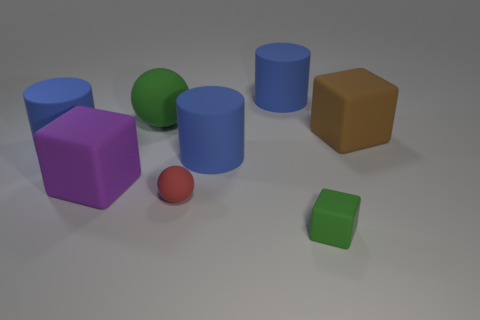What color is the other big rubber thing that is the same shape as the large purple rubber thing?
Keep it short and to the point. Brown. What material is the tiny cube that is the same color as the large ball?
Offer a very short reply. Rubber. Is there another large thing that has the same shape as the red thing?
Offer a terse response. Yes. What number of other things are there of the same color as the small matte block?
Ensure brevity in your answer.  1. Is the size of the rubber block behind the purple cube the same as the green object that is behind the tiny red matte object?
Keep it short and to the point. Yes. There is a cube that is in front of the big matte cube that is left of the tiny sphere; how big is it?
Ensure brevity in your answer.  Small. There is a block that is both in front of the large brown thing and behind the tiny red matte ball; what is its material?
Offer a very short reply. Rubber. The tiny rubber block is what color?
Ensure brevity in your answer.  Green. What shape is the green matte object that is to the right of the large green rubber sphere?
Provide a succinct answer. Cube. There is a large rubber block that is left of the large blue object that is behind the green sphere; is there a tiny red rubber object that is on the left side of it?
Your answer should be very brief. No. 